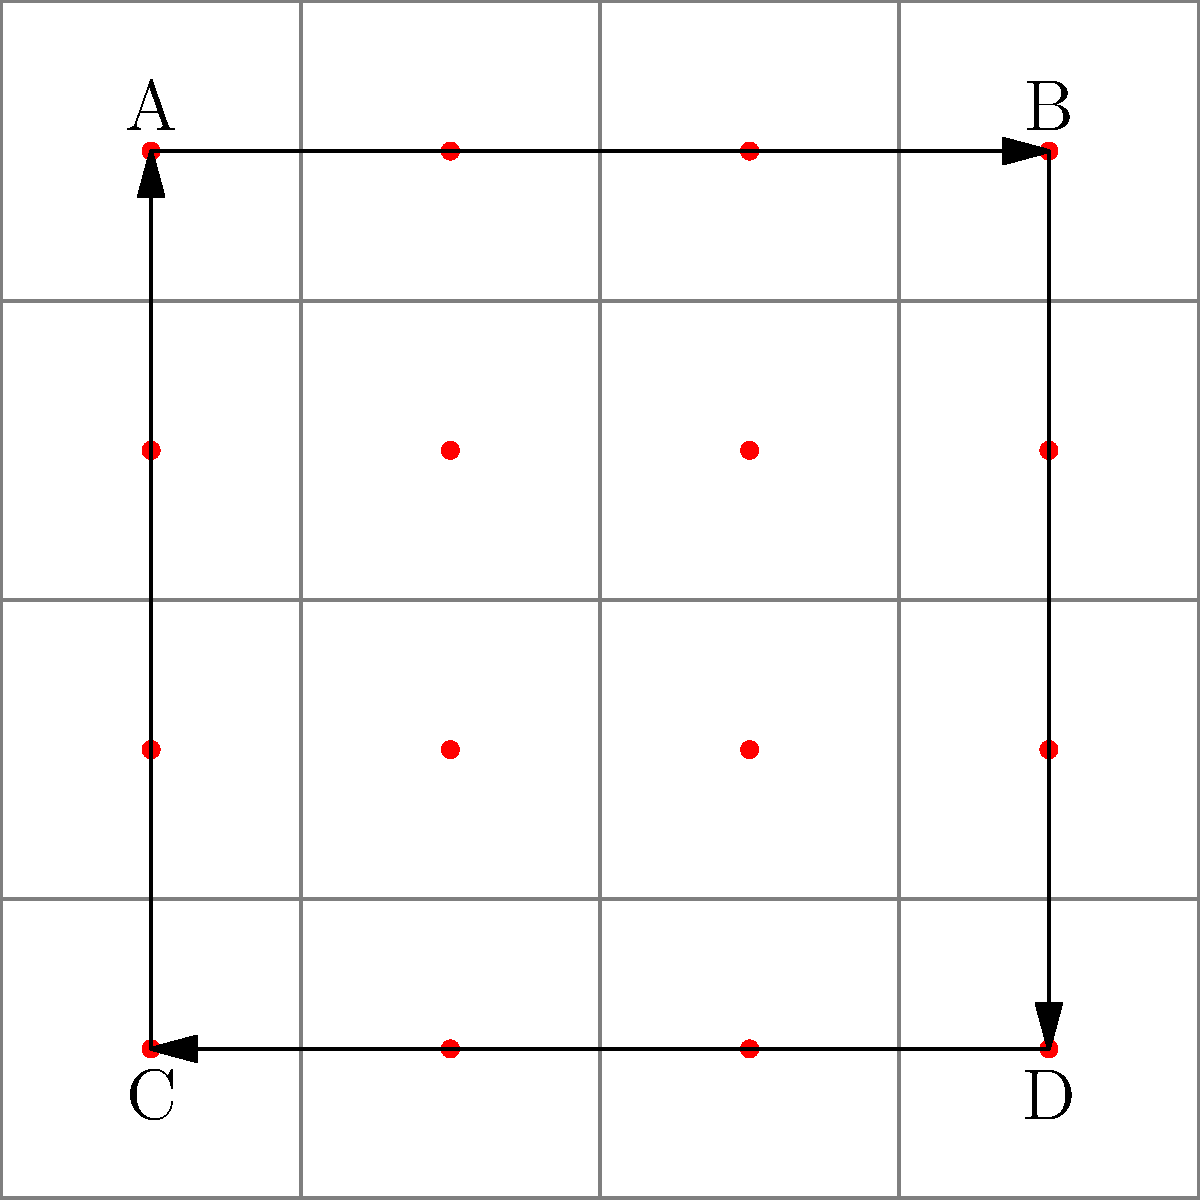In a parallel computing environment, you need to map a circular pipeline algorithm to a 4x4 grid of interconnected nodes. The algorithm requires data to flow in the order A → B → D → C → A. What is the minimum number of communication steps required to complete one full cycle of the algorithm, assuming each step allows simultaneous communication between adjacent nodes? To solve this problem, we need to analyze the path of data flow and count the minimum number of communication steps:

1. A → B: This requires 3 steps to move data from A to B (moving right across the top row).
2. B → D: This requires 3 steps to move data from B to D (moving down the rightmost column).
3. D → C: This requires 3 steps to move data from D to C (moving left across the bottom row).
4. C → A: This requires 3 steps to move data from C to A (moving up the leftmost column).

Each of these movements can occur simultaneously with others, as long as they don't interfere with each other. The total path length is 12 steps (3 + 3 + 3 + 3).

However, we need to consider that some steps can overlap. For example, while data is moving from B to D, the path from A to B is clear, so new data can start flowing from A.

The optimal schedule would look like this:
- Steps 1-3: A → B
- Steps 4-6: B → D (and simultaneously, new data A → middle of top row)
- Steps 7-9: D → C (simultaneously, previous A → B, and new data A → middle of top row)
- Steps 10-12: C → A (simultaneously, previous D → C, B → D, and A → B)

Therefore, the minimum number of communication steps required to complete one full cycle is 12.
Answer: 12 steps 